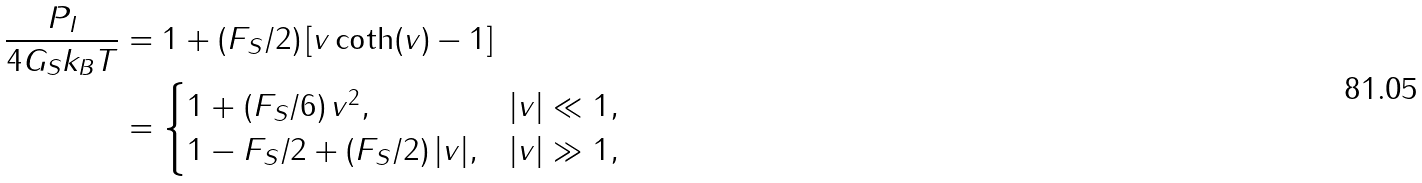<formula> <loc_0><loc_0><loc_500><loc_500>\frac { P _ { I } } { 4 G _ { S } k _ { B } T } & = 1 + ( F _ { S } / 2 ) \, [ v \coth ( v ) - 1 ] \\ & = \begin{cases} 1 + ( F _ { S } / 6 ) \, v ^ { 2 } , & | v | \ll 1 , \\ 1 - F _ { S } / 2 + ( F _ { S } / 2 ) \, | v | , & | v | \gg 1 , \end{cases}</formula> 